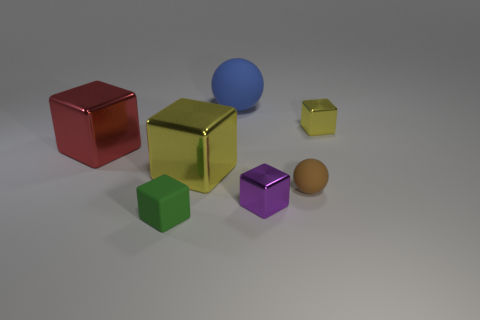Subtract all yellow spheres. How many yellow cubes are left? 2 Subtract all green blocks. How many blocks are left? 4 Subtract all matte cubes. How many cubes are left? 4 Add 3 small purple blocks. How many objects exist? 10 Subtract all blocks. How many objects are left? 2 Subtract all blue cubes. Subtract all blue balls. How many cubes are left? 5 Add 4 small purple metal objects. How many small purple metal objects exist? 5 Subtract 0 blue blocks. How many objects are left? 7 Subtract all brown blocks. Subtract all yellow things. How many objects are left? 5 Add 5 large blue rubber objects. How many large blue rubber objects are left? 6 